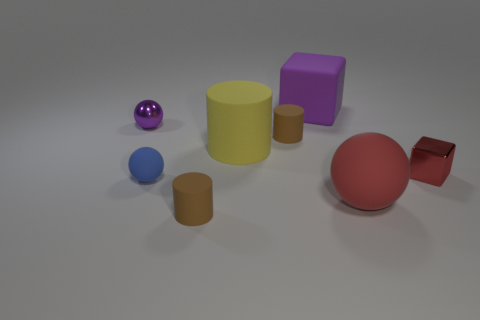Subtract 1 cylinders. How many cylinders are left? 2 Subtract all brown cylinders. How many cylinders are left? 1 Add 1 tiny purple metal objects. How many objects exist? 9 Subtract all cylinders. How many objects are left? 5 Add 8 large yellow matte spheres. How many large yellow matte spheres exist? 8 Subtract 0 yellow balls. How many objects are left? 8 Subtract all big spheres. Subtract all metallic cubes. How many objects are left? 6 Add 4 tiny blue spheres. How many tiny blue spheres are left? 5 